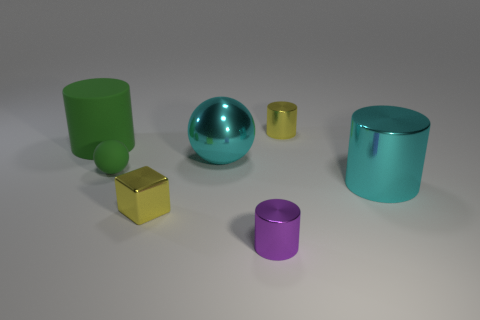Add 1 small green rubber spheres. How many objects exist? 8 Subtract all spheres. How many objects are left? 5 Subtract all tiny yellow metallic objects. Subtract all big green matte objects. How many objects are left? 4 Add 3 small metallic cubes. How many small metallic cubes are left? 4 Add 6 small green balls. How many small green balls exist? 7 Subtract 0 blue cubes. How many objects are left? 7 